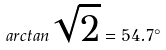Convert formula to latex. <formula><loc_0><loc_0><loc_500><loc_500>a r c t a n \sqrt { 2 } = 5 4 . 7 ^ { \circ }</formula> 